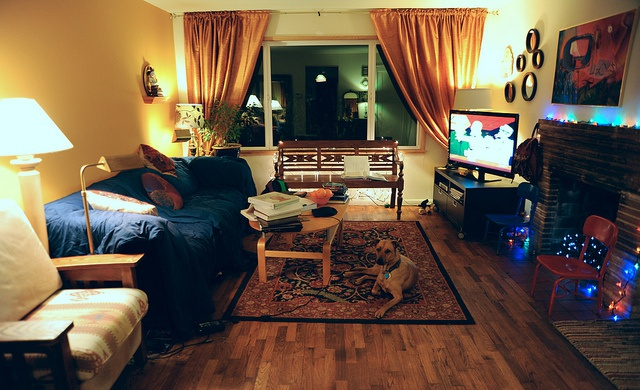Describe the objects in this image and their specific colors. I can see chair in gray, black, tan, beige, and maroon tones, couch in gray, black, darkblue, lightblue, and blue tones, bench in gray, maroon, black, khaki, and tan tones, tv in gray, lightblue, black, salmon, and khaki tones, and chair in gray, maroon, black, navy, and darkblue tones in this image. 